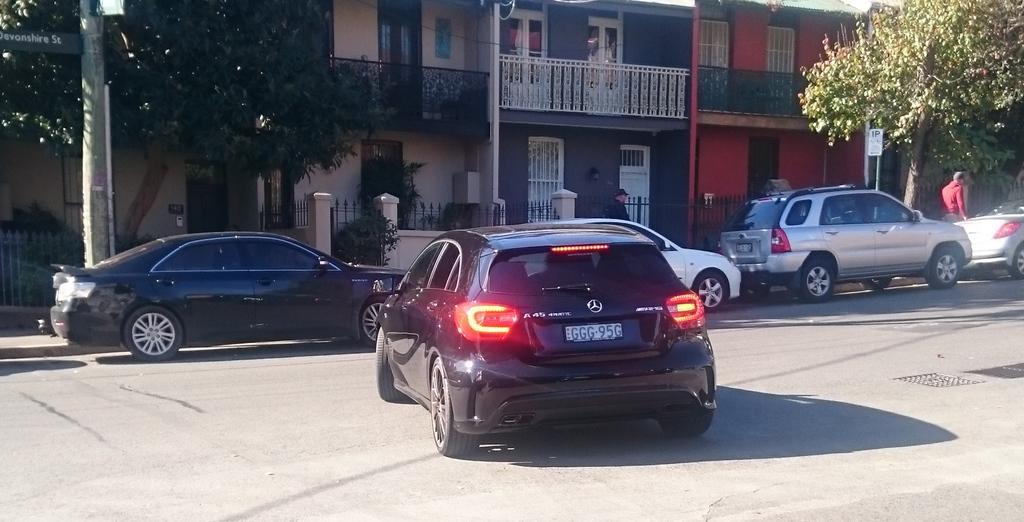How would you summarize this image in a sentence or two? In this image I can see road and on it I can see few cars. I can also see shadow on this road. In the background I can see trees, poles, a white color sign board, buildings and I can see few people are standing. 